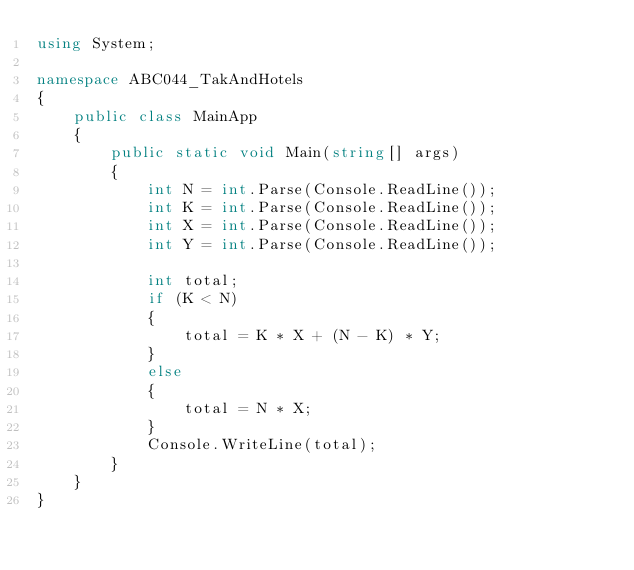Convert code to text. <code><loc_0><loc_0><loc_500><loc_500><_C#_>using System;

namespace ABC044_TakAndHotels
{
    public class MainApp
    {
        public static void Main(string[] args)
        {
            int N = int.Parse(Console.ReadLine());
            int K = int.Parse(Console.ReadLine());
            int X = int.Parse(Console.ReadLine());
            int Y = int.Parse(Console.ReadLine());

            int total;
            if (K < N) 
            {
                total = K * X + (N - K) * Y;
            }
            else
            {
                total = N * X;
            }
            Console.WriteLine(total);
        }
    }
}
</code> 